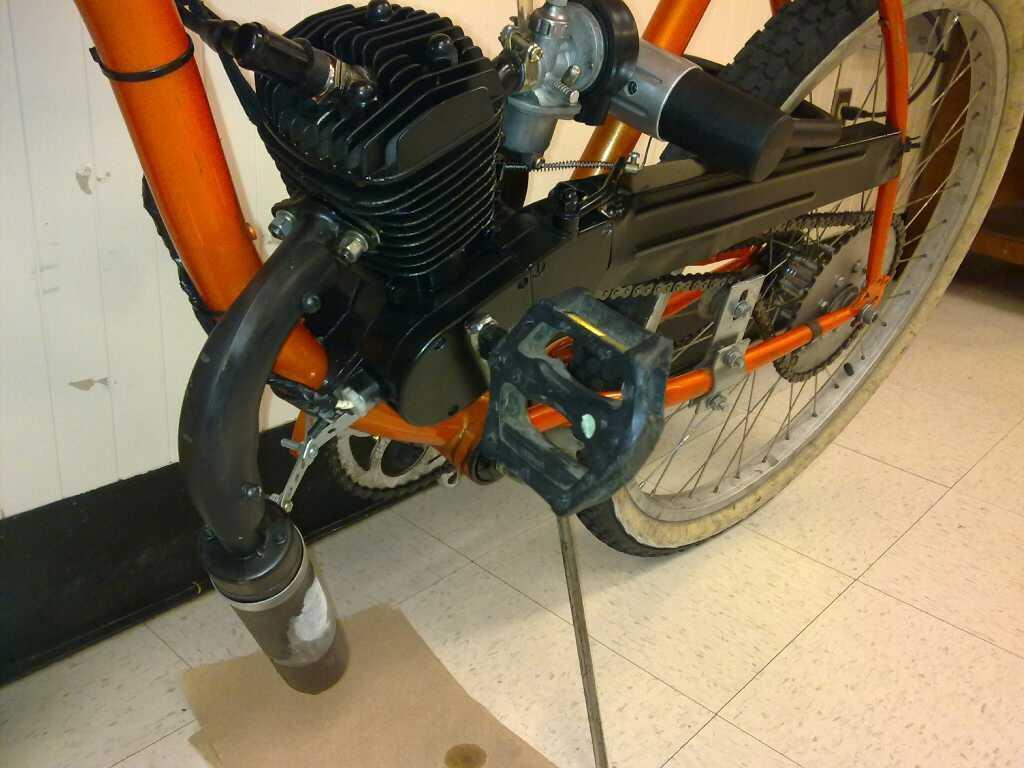Can you describe this image briefly? In this image I can see a motorcycle on the floor. In the background there is a wall. At the bottom there is a paper placed on the floor. 